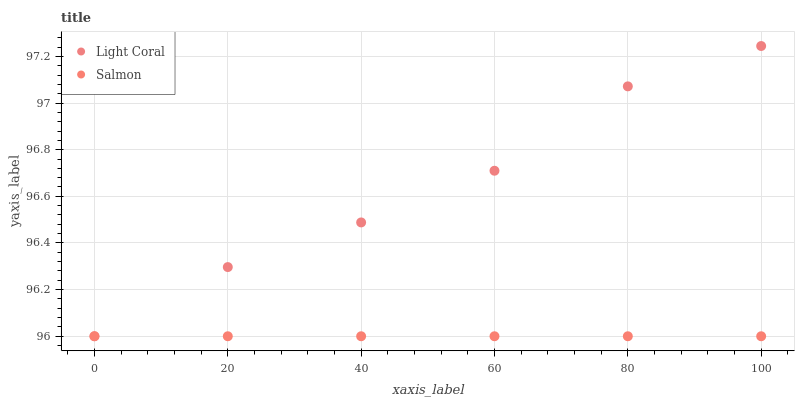Does Salmon have the minimum area under the curve?
Answer yes or no. Yes. Does Light Coral have the maximum area under the curve?
Answer yes or no. Yes. Does Salmon have the maximum area under the curve?
Answer yes or no. No. Is Salmon the smoothest?
Answer yes or no. Yes. Is Light Coral the roughest?
Answer yes or no. Yes. Is Salmon the roughest?
Answer yes or no. No. Does Light Coral have the lowest value?
Answer yes or no. Yes. Does Light Coral have the highest value?
Answer yes or no. Yes. Does Salmon have the highest value?
Answer yes or no. No. Does Light Coral intersect Salmon?
Answer yes or no. Yes. Is Light Coral less than Salmon?
Answer yes or no. No. Is Light Coral greater than Salmon?
Answer yes or no. No. 